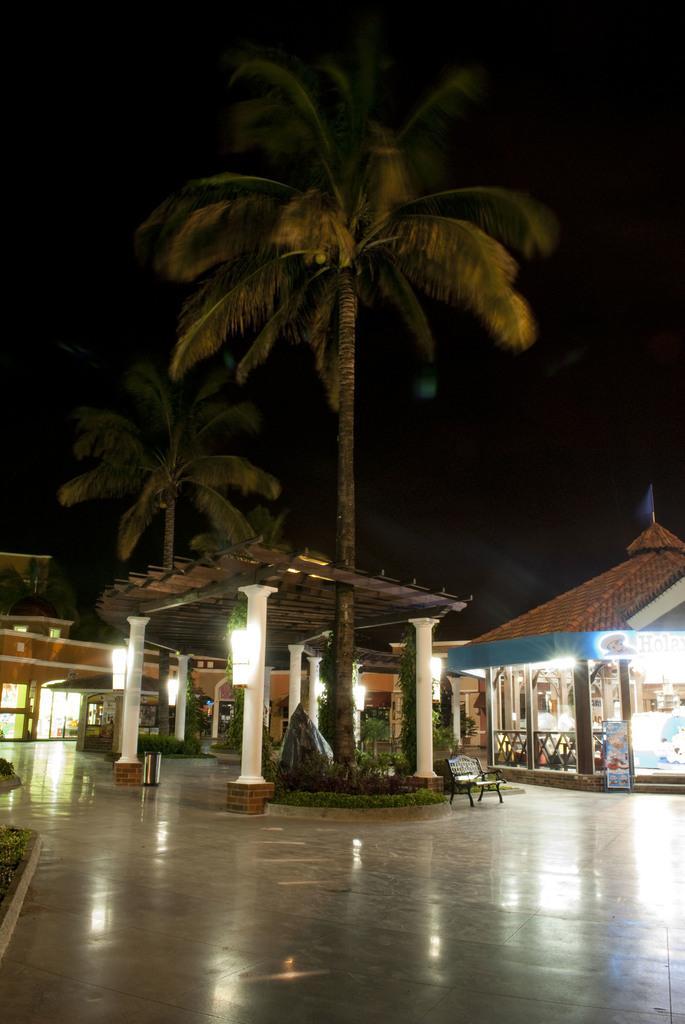Describe this image in one or two sentences. In this image there is resort, in the middle there is a roof and trees, beside the roof there is a bench. 